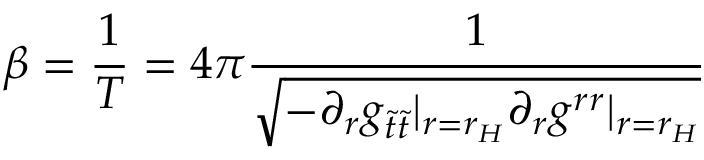Convert formula to latex. <formula><loc_0><loc_0><loc_500><loc_500>\beta = \frac { 1 } { T } = 4 \pi \frac { 1 } { \sqrt { - \partial _ { r } g _ { \tilde { t } \tilde { t } } | _ { r = r _ { H } } \partial _ { r } g ^ { r r } | _ { r = r _ { H } } } }</formula> 